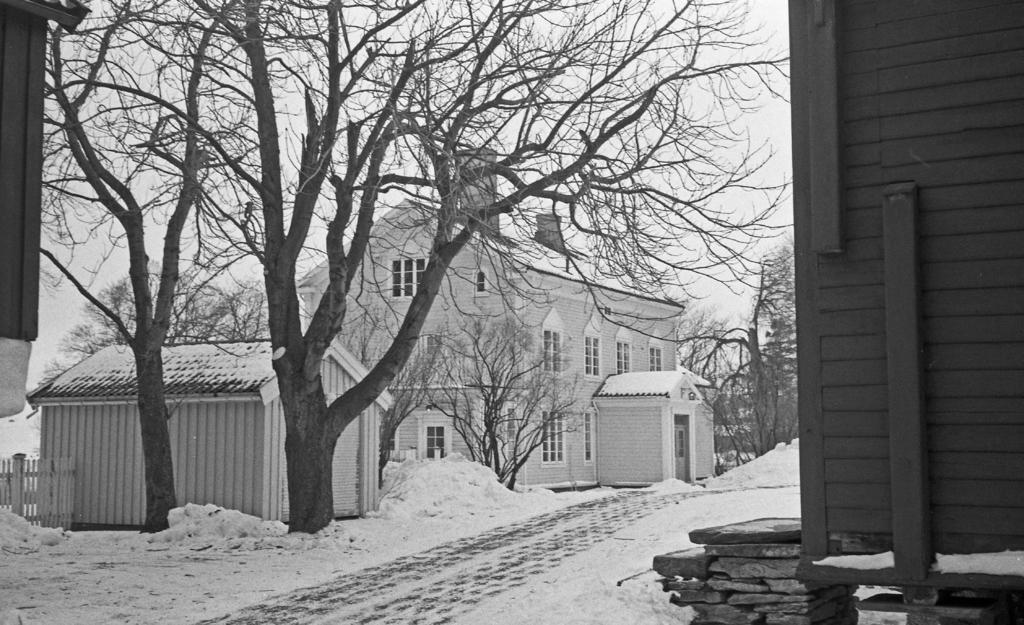What is the color scheme of the image? The image is black and white. What type of structures can be seen in the image? There are buildings with windows in the image. What type of terrain is present in the image? There are stones and a pathway in the image. What type of barrier is present in the image? There is a fence in the image. What type of vegetation is present in the image? There are trees in the image. What weather condition is depicted in the image? There is snow visible in the image. What part of the natural environment is visible in the image? The sky is visible in the image. What type of picture is hanging on the wall in the image? There is no picture hanging on the wall in the image; it is a black and white scene with buildings, stones, a pathway, a fence, trees, snow, and a visible sky. What type of beast can be seen roaming in the image? There are no beasts present in the image; it is a scene of buildings, stones, a pathway, a fence, trees, snow, and a visible sky. 